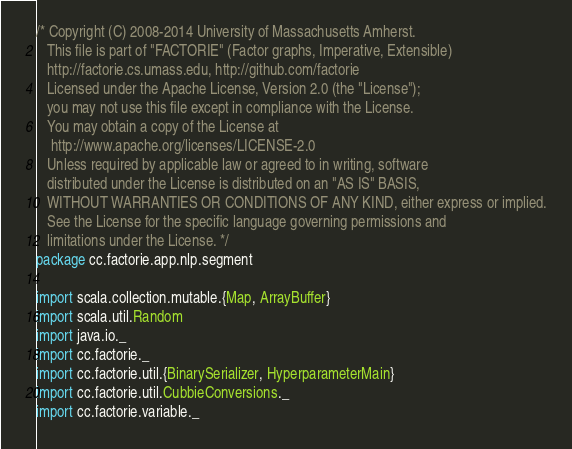Convert code to text. <code><loc_0><loc_0><loc_500><loc_500><_Scala_>/* Copyright (C) 2008-2014 University of Massachusetts Amherst.
   This file is part of "FACTORIE" (Factor graphs, Imperative, Extensible)
   http://factorie.cs.umass.edu, http://github.com/factorie
   Licensed under the Apache License, Version 2.0 (the "License");
   you may not use this file except in compliance with the License.
   You may obtain a copy of the License at
    http://www.apache.org/licenses/LICENSE-2.0
   Unless required by applicable law or agreed to in writing, software
   distributed under the License is distributed on an "AS IS" BASIS,
   WITHOUT WARRANTIES OR CONDITIONS OF ANY KIND, either express or implied.
   See the License for the specific language governing permissions and
   limitations under the License. */
package cc.factorie.app.nlp.segment

import scala.collection.mutable.{Map, ArrayBuffer}
import scala.util.Random
import java.io._
import cc.factorie._
import cc.factorie.util.{BinarySerializer, HyperparameterMain}
import cc.factorie.util.CubbieConversions._
import cc.factorie.variable._</code> 